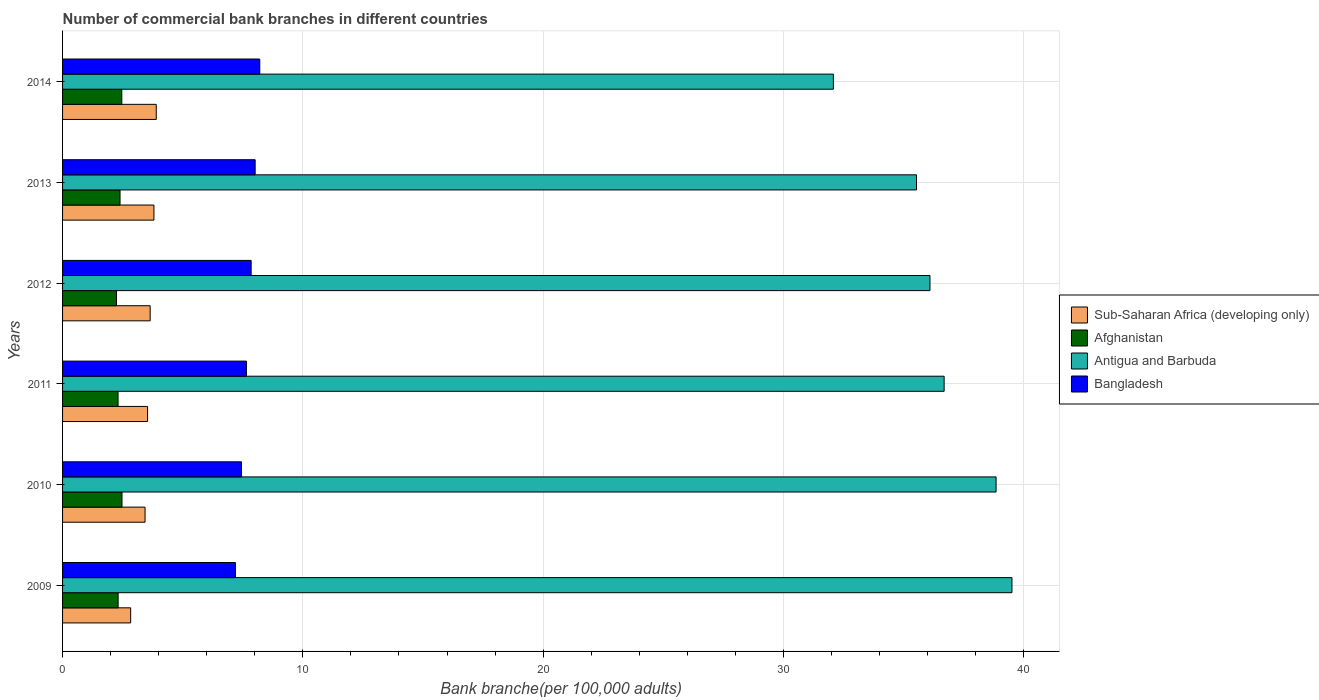How many different coloured bars are there?
Make the answer very short. 4. Are the number of bars on each tick of the Y-axis equal?
Provide a succinct answer. Yes. What is the label of the 1st group of bars from the top?
Give a very brief answer. 2014. What is the number of commercial bank branches in Antigua and Barbuda in 2009?
Keep it short and to the point. 39.51. Across all years, what is the maximum number of commercial bank branches in Afghanistan?
Provide a succinct answer. 2.47. Across all years, what is the minimum number of commercial bank branches in Antigua and Barbuda?
Your answer should be very brief. 32.08. What is the total number of commercial bank branches in Bangladesh in the graph?
Provide a succinct answer. 46.36. What is the difference between the number of commercial bank branches in Afghanistan in 2010 and that in 2011?
Provide a short and direct response. 0.16. What is the difference between the number of commercial bank branches in Bangladesh in 2014 and the number of commercial bank branches in Afghanistan in 2013?
Offer a terse response. 5.82. What is the average number of commercial bank branches in Afghanistan per year?
Provide a succinct answer. 2.37. In the year 2009, what is the difference between the number of commercial bank branches in Antigua and Barbuda and number of commercial bank branches in Sub-Saharan Africa (developing only)?
Offer a terse response. 36.68. In how many years, is the number of commercial bank branches in Antigua and Barbuda greater than 6 ?
Provide a succinct answer. 6. What is the ratio of the number of commercial bank branches in Afghanistan in 2012 to that in 2013?
Keep it short and to the point. 0.94. Is the number of commercial bank branches in Afghanistan in 2010 less than that in 2014?
Provide a succinct answer. No. Is the difference between the number of commercial bank branches in Antigua and Barbuda in 2011 and 2013 greater than the difference between the number of commercial bank branches in Sub-Saharan Africa (developing only) in 2011 and 2013?
Your answer should be very brief. Yes. What is the difference between the highest and the second highest number of commercial bank branches in Sub-Saharan Africa (developing only)?
Offer a very short reply. 0.1. What is the difference between the highest and the lowest number of commercial bank branches in Sub-Saharan Africa (developing only)?
Ensure brevity in your answer.  1.07. In how many years, is the number of commercial bank branches in Bangladesh greater than the average number of commercial bank branches in Bangladesh taken over all years?
Give a very brief answer. 3. Is it the case that in every year, the sum of the number of commercial bank branches in Antigua and Barbuda and number of commercial bank branches in Afghanistan is greater than the sum of number of commercial bank branches in Bangladesh and number of commercial bank branches in Sub-Saharan Africa (developing only)?
Your answer should be compact. Yes. What does the 3rd bar from the top in 2011 represents?
Give a very brief answer. Afghanistan. What does the 3rd bar from the bottom in 2014 represents?
Offer a terse response. Antigua and Barbuda. How many years are there in the graph?
Keep it short and to the point. 6. What is the difference between two consecutive major ticks on the X-axis?
Provide a succinct answer. 10. How many legend labels are there?
Offer a terse response. 4. How are the legend labels stacked?
Provide a succinct answer. Vertical. What is the title of the graph?
Offer a very short reply. Number of commercial bank branches in different countries. Does "Slovak Republic" appear as one of the legend labels in the graph?
Offer a very short reply. No. What is the label or title of the X-axis?
Ensure brevity in your answer.  Bank branche(per 100,0 adults). What is the label or title of the Y-axis?
Provide a short and direct response. Years. What is the Bank branche(per 100,000 adults) of Sub-Saharan Africa (developing only) in 2009?
Give a very brief answer. 2.83. What is the Bank branche(per 100,000 adults) of Afghanistan in 2009?
Your response must be concise. 2.31. What is the Bank branche(per 100,000 adults) of Antigua and Barbuda in 2009?
Your answer should be compact. 39.51. What is the Bank branche(per 100,000 adults) in Bangladesh in 2009?
Offer a very short reply. 7.19. What is the Bank branche(per 100,000 adults) in Sub-Saharan Africa (developing only) in 2010?
Provide a short and direct response. 3.43. What is the Bank branche(per 100,000 adults) of Afghanistan in 2010?
Offer a very short reply. 2.47. What is the Bank branche(per 100,000 adults) of Antigua and Barbuda in 2010?
Your answer should be compact. 38.85. What is the Bank branche(per 100,000 adults) in Bangladesh in 2010?
Offer a very short reply. 7.44. What is the Bank branche(per 100,000 adults) in Sub-Saharan Africa (developing only) in 2011?
Offer a very short reply. 3.54. What is the Bank branche(per 100,000 adults) of Afghanistan in 2011?
Offer a terse response. 2.31. What is the Bank branche(per 100,000 adults) of Antigua and Barbuda in 2011?
Provide a succinct answer. 36.69. What is the Bank branche(per 100,000 adults) in Bangladesh in 2011?
Your response must be concise. 7.65. What is the Bank branche(per 100,000 adults) in Sub-Saharan Africa (developing only) in 2012?
Offer a very short reply. 3.65. What is the Bank branche(per 100,000 adults) in Afghanistan in 2012?
Offer a terse response. 2.24. What is the Bank branche(per 100,000 adults) in Antigua and Barbuda in 2012?
Keep it short and to the point. 36.1. What is the Bank branche(per 100,000 adults) of Bangladesh in 2012?
Your response must be concise. 7.85. What is the Bank branche(per 100,000 adults) of Sub-Saharan Africa (developing only) in 2013?
Provide a short and direct response. 3.8. What is the Bank branche(per 100,000 adults) of Afghanistan in 2013?
Your response must be concise. 2.39. What is the Bank branche(per 100,000 adults) in Antigua and Barbuda in 2013?
Offer a terse response. 35.54. What is the Bank branche(per 100,000 adults) of Bangladesh in 2013?
Your answer should be compact. 8.02. What is the Bank branche(per 100,000 adults) of Sub-Saharan Africa (developing only) in 2014?
Ensure brevity in your answer.  3.9. What is the Bank branche(per 100,000 adults) in Afghanistan in 2014?
Your answer should be very brief. 2.47. What is the Bank branche(per 100,000 adults) of Antigua and Barbuda in 2014?
Offer a terse response. 32.08. What is the Bank branche(per 100,000 adults) of Bangladesh in 2014?
Your answer should be compact. 8.21. Across all years, what is the maximum Bank branche(per 100,000 adults) in Sub-Saharan Africa (developing only)?
Provide a succinct answer. 3.9. Across all years, what is the maximum Bank branche(per 100,000 adults) of Afghanistan?
Offer a very short reply. 2.47. Across all years, what is the maximum Bank branche(per 100,000 adults) in Antigua and Barbuda?
Keep it short and to the point. 39.51. Across all years, what is the maximum Bank branche(per 100,000 adults) of Bangladesh?
Provide a succinct answer. 8.21. Across all years, what is the minimum Bank branche(per 100,000 adults) in Sub-Saharan Africa (developing only)?
Offer a terse response. 2.83. Across all years, what is the minimum Bank branche(per 100,000 adults) of Afghanistan?
Your answer should be compact. 2.24. Across all years, what is the minimum Bank branche(per 100,000 adults) in Antigua and Barbuda?
Your answer should be very brief. 32.08. Across all years, what is the minimum Bank branche(per 100,000 adults) in Bangladesh?
Your response must be concise. 7.19. What is the total Bank branche(per 100,000 adults) in Sub-Saharan Africa (developing only) in the graph?
Ensure brevity in your answer.  21.15. What is the total Bank branche(per 100,000 adults) in Afghanistan in the graph?
Give a very brief answer. 14.2. What is the total Bank branche(per 100,000 adults) in Antigua and Barbuda in the graph?
Your answer should be very brief. 218.77. What is the total Bank branche(per 100,000 adults) of Bangladesh in the graph?
Keep it short and to the point. 46.36. What is the difference between the Bank branche(per 100,000 adults) of Sub-Saharan Africa (developing only) in 2009 and that in 2010?
Your answer should be very brief. -0.6. What is the difference between the Bank branche(per 100,000 adults) of Afghanistan in 2009 and that in 2010?
Offer a very short reply. -0.16. What is the difference between the Bank branche(per 100,000 adults) of Antigua and Barbuda in 2009 and that in 2010?
Your response must be concise. 0.66. What is the difference between the Bank branche(per 100,000 adults) of Bangladesh in 2009 and that in 2010?
Offer a very short reply. -0.25. What is the difference between the Bank branche(per 100,000 adults) of Sub-Saharan Africa (developing only) in 2009 and that in 2011?
Offer a very short reply. -0.7. What is the difference between the Bank branche(per 100,000 adults) of Afghanistan in 2009 and that in 2011?
Your answer should be compact. 0. What is the difference between the Bank branche(per 100,000 adults) of Antigua and Barbuda in 2009 and that in 2011?
Your response must be concise. 2.82. What is the difference between the Bank branche(per 100,000 adults) of Bangladesh in 2009 and that in 2011?
Offer a terse response. -0.46. What is the difference between the Bank branche(per 100,000 adults) in Sub-Saharan Africa (developing only) in 2009 and that in 2012?
Offer a very short reply. -0.81. What is the difference between the Bank branche(per 100,000 adults) in Afghanistan in 2009 and that in 2012?
Provide a succinct answer. 0.07. What is the difference between the Bank branche(per 100,000 adults) of Antigua and Barbuda in 2009 and that in 2012?
Provide a short and direct response. 3.41. What is the difference between the Bank branche(per 100,000 adults) in Bangladesh in 2009 and that in 2012?
Give a very brief answer. -0.65. What is the difference between the Bank branche(per 100,000 adults) of Sub-Saharan Africa (developing only) in 2009 and that in 2013?
Make the answer very short. -0.97. What is the difference between the Bank branche(per 100,000 adults) of Afghanistan in 2009 and that in 2013?
Make the answer very short. -0.08. What is the difference between the Bank branche(per 100,000 adults) in Antigua and Barbuda in 2009 and that in 2013?
Provide a succinct answer. 3.97. What is the difference between the Bank branche(per 100,000 adults) in Bangladesh in 2009 and that in 2013?
Provide a succinct answer. -0.82. What is the difference between the Bank branche(per 100,000 adults) in Sub-Saharan Africa (developing only) in 2009 and that in 2014?
Keep it short and to the point. -1.07. What is the difference between the Bank branche(per 100,000 adults) of Afghanistan in 2009 and that in 2014?
Offer a terse response. -0.15. What is the difference between the Bank branche(per 100,000 adults) in Antigua and Barbuda in 2009 and that in 2014?
Provide a succinct answer. 7.43. What is the difference between the Bank branche(per 100,000 adults) of Bangladesh in 2009 and that in 2014?
Provide a succinct answer. -1.01. What is the difference between the Bank branche(per 100,000 adults) in Sub-Saharan Africa (developing only) in 2010 and that in 2011?
Provide a short and direct response. -0.11. What is the difference between the Bank branche(per 100,000 adults) in Afghanistan in 2010 and that in 2011?
Offer a very short reply. 0.16. What is the difference between the Bank branche(per 100,000 adults) in Antigua and Barbuda in 2010 and that in 2011?
Ensure brevity in your answer.  2.16. What is the difference between the Bank branche(per 100,000 adults) in Bangladesh in 2010 and that in 2011?
Give a very brief answer. -0.21. What is the difference between the Bank branche(per 100,000 adults) in Sub-Saharan Africa (developing only) in 2010 and that in 2012?
Your response must be concise. -0.21. What is the difference between the Bank branche(per 100,000 adults) in Afghanistan in 2010 and that in 2012?
Offer a very short reply. 0.23. What is the difference between the Bank branche(per 100,000 adults) in Antigua and Barbuda in 2010 and that in 2012?
Give a very brief answer. 2.75. What is the difference between the Bank branche(per 100,000 adults) of Bangladesh in 2010 and that in 2012?
Provide a succinct answer. -0.4. What is the difference between the Bank branche(per 100,000 adults) of Sub-Saharan Africa (developing only) in 2010 and that in 2013?
Your answer should be very brief. -0.37. What is the difference between the Bank branche(per 100,000 adults) of Afghanistan in 2010 and that in 2013?
Give a very brief answer. 0.08. What is the difference between the Bank branche(per 100,000 adults) of Antigua and Barbuda in 2010 and that in 2013?
Offer a terse response. 3.31. What is the difference between the Bank branche(per 100,000 adults) of Bangladesh in 2010 and that in 2013?
Keep it short and to the point. -0.57. What is the difference between the Bank branche(per 100,000 adults) in Sub-Saharan Africa (developing only) in 2010 and that in 2014?
Give a very brief answer. -0.47. What is the difference between the Bank branche(per 100,000 adults) of Afghanistan in 2010 and that in 2014?
Make the answer very short. 0.01. What is the difference between the Bank branche(per 100,000 adults) of Antigua and Barbuda in 2010 and that in 2014?
Your answer should be very brief. 6.77. What is the difference between the Bank branche(per 100,000 adults) in Bangladesh in 2010 and that in 2014?
Give a very brief answer. -0.76. What is the difference between the Bank branche(per 100,000 adults) in Sub-Saharan Africa (developing only) in 2011 and that in 2012?
Offer a very short reply. -0.11. What is the difference between the Bank branche(per 100,000 adults) of Afghanistan in 2011 and that in 2012?
Offer a terse response. 0.06. What is the difference between the Bank branche(per 100,000 adults) of Antigua and Barbuda in 2011 and that in 2012?
Make the answer very short. 0.59. What is the difference between the Bank branche(per 100,000 adults) of Bangladesh in 2011 and that in 2012?
Make the answer very short. -0.2. What is the difference between the Bank branche(per 100,000 adults) in Sub-Saharan Africa (developing only) in 2011 and that in 2013?
Your answer should be very brief. -0.26. What is the difference between the Bank branche(per 100,000 adults) of Afghanistan in 2011 and that in 2013?
Give a very brief answer. -0.08. What is the difference between the Bank branche(per 100,000 adults) in Antigua and Barbuda in 2011 and that in 2013?
Keep it short and to the point. 1.15. What is the difference between the Bank branche(per 100,000 adults) of Bangladesh in 2011 and that in 2013?
Make the answer very short. -0.36. What is the difference between the Bank branche(per 100,000 adults) in Sub-Saharan Africa (developing only) in 2011 and that in 2014?
Your answer should be compact. -0.36. What is the difference between the Bank branche(per 100,000 adults) in Afghanistan in 2011 and that in 2014?
Your answer should be very brief. -0.16. What is the difference between the Bank branche(per 100,000 adults) of Antigua and Barbuda in 2011 and that in 2014?
Offer a very short reply. 4.61. What is the difference between the Bank branche(per 100,000 adults) of Bangladesh in 2011 and that in 2014?
Your answer should be very brief. -0.56. What is the difference between the Bank branche(per 100,000 adults) of Sub-Saharan Africa (developing only) in 2012 and that in 2013?
Provide a short and direct response. -0.16. What is the difference between the Bank branche(per 100,000 adults) in Afghanistan in 2012 and that in 2013?
Provide a short and direct response. -0.15. What is the difference between the Bank branche(per 100,000 adults) of Antigua and Barbuda in 2012 and that in 2013?
Ensure brevity in your answer.  0.56. What is the difference between the Bank branche(per 100,000 adults) of Bangladesh in 2012 and that in 2013?
Give a very brief answer. -0.17. What is the difference between the Bank branche(per 100,000 adults) of Sub-Saharan Africa (developing only) in 2012 and that in 2014?
Give a very brief answer. -0.25. What is the difference between the Bank branche(per 100,000 adults) of Afghanistan in 2012 and that in 2014?
Your answer should be compact. -0.22. What is the difference between the Bank branche(per 100,000 adults) in Antigua and Barbuda in 2012 and that in 2014?
Your answer should be very brief. 4.02. What is the difference between the Bank branche(per 100,000 adults) in Bangladesh in 2012 and that in 2014?
Your response must be concise. -0.36. What is the difference between the Bank branche(per 100,000 adults) of Sub-Saharan Africa (developing only) in 2013 and that in 2014?
Your answer should be compact. -0.1. What is the difference between the Bank branche(per 100,000 adults) in Afghanistan in 2013 and that in 2014?
Keep it short and to the point. -0.07. What is the difference between the Bank branche(per 100,000 adults) of Antigua and Barbuda in 2013 and that in 2014?
Make the answer very short. 3.46. What is the difference between the Bank branche(per 100,000 adults) in Bangladesh in 2013 and that in 2014?
Offer a terse response. -0.19. What is the difference between the Bank branche(per 100,000 adults) of Sub-Saharan Africa (developing only) in 2009 and the Bank branche(per 100,000 adults) of Afghanistan in 2010?
Provide a succinct answer. 0.36. What is the difference between the Bank branche(per 100,000 adults) of Sub-Saharan Africa (developing only) in 2009 and the Bank branche(per 100,000 adults) of Antigua and Barbuda in 2010?
Keep it short and to the point. -36.02. What is the difference between the Bank branche(per 100,000 adults) of Sub-Saharan Africa (developing only) in 2009 and the Bank branche(per 100,000 adults) of Bangladesh in 2010?
Give a very brief answer. -4.61. What is the difference between the Bank branche(per 100,000 adults) of Afghanistan in 2009 and the Bank branche(per 100,000 adults) of Antigua and Barbuda in 2010?
Your answer should be very brief. -36.54. What is the difference between the Bank branche(per 100,000 adults) of Afghanistan in 2009 and the Bank branche(per 100,000 adults) of Bangladesh in 2010?
Make the answer very short. -5.13. What is the difference between the Bank branche(per 100,000 adults) in Antigua and Barbuda in 2009 and the Bank branche(per 100,000 adults) in Bangladesh in 2010?
Offer a terse response. 32.07. What is the difference between the Bank branche(per 100,000 adults) of Sub-Saharan Africa (developing only) in 2009 and the Bank branche(per 100,000 adults) of Afghanistan in 2011?
Your answer should be very brief. 0.52. What is the difference between the Bank branche(per 100,000 adults) of Sub-Saharan Africa (developing only) in 2009 and the Bank branche(per 100,000 adults) of Antigua and Barbuda in 2011?
Your response must be concise. -33.85. What is the difference between the Bank branche(per 100,000 adults) in Sub-Saharan Africa (developing only) in 2009 and the Bank branche(per 100,000 adults) in Bangladesh in 2011?
Give a very brief answer. -4.82. What is the difference between the Bank branche(per 100,000 adults) of Afghanistan in 2009 and the Bank branche(per 100,000 adults) of Antigua and Barbuda in 2011?
Your response must be concise. -34.38. What is the difference between the Bank branche(per 100,000 adults) of Afghanistan in 2009 and the Bank branche(per 100,000 adults) of Bangladesh in 2011?
Provide a succinct answer. -5.34. What is the difference between the Bank branche(per 100,000 adults) in Antigua and Barbuda in 2009 and the Bank branche(per 100,000 adults) in Bangladesh in 2011?
Ensure brevity in your answer.  31.86. What is the difference between the Bank branche(per 100,000 adults) in Sub-Saharan Africa (developing only) in 2009 and the Bank branche(per 100,000 adults) in Afghanistan in 2012?
Make the answer very short. 0.59. What is the difference between the Bank branche(per 100,000 adults) in Sub-Saharan Africa (developing only) in 2009 and the Bank branche(per 100,000 adults) in Antigua and Barbuda in 2012?
Provide a short and direct response. -33.26. What is the difference between the Bank branche(per 100,000 adults) in Sub-Saharan Africa (developing only) in 2009 and the Bank branche(per 100,000 adults) in Bangladesh in 2012?
Make the answer very short. -5.01. What is the difference between the Bank branche(per 100,000 adults) of Afghanistan in 2009 and the Bank branche(per 100,000 adults) of Antigua and Barbuda in 2012?
Keep it short and to the point. -33.79. What is the difference between the Bank branche(per 100,000 adults) of Afghanistan in 2009 and the Bank branche(per 100,000 adults) of Bangladesh in 2012?
Your answer should be compact. -5.54. What is the difference between the Bank branche(per 100,000 adults) of Antigua and Barbuda in 2009 and the Bank branche(per 100,000 adults) of Bangladesh in 2012?
Your answer should be very brief. 31.66. What is the difference between the Bank branche(per 100,000 adults) of Sub-Saharan Africa (developing only) in 2009 and the Bank branche(per 100,000 adults) of Afghanistan in 2013?
Your answer should be very brief. 0.44. What is the difference between the Bank branche(per 100,000 adults) of Sub-Saharan Africa (developing only) in 2009 and the Bank branche(per 100,000 adults) of Antigua and Barbuda in 2013?
Provide a short and direct response. -32.7. What is the difference between the Bank branche(per 100,000 adults) of Sub-Saharan Africa (developing only) in 2009 and the Bank branche(per 100,000 adults) of Bangladesh in 2013?
Ensure brevity in your answer.  -5.18. What is the difference between the Bank branche(per 100,000 adults) of Afghanistan in 2009 and the Bank branche(per 100,000 adults) of Antigua and Barbuda in 2013?
Keep it short and to the point. -33.23. What is the difference between the Bank branche(per 100,000 adults) of Afghanistan in 2009 and the Bank branche(per 100,000 adults) of Bangladesh in 2013?
Offer a very short reply. -5.7. What is the difference between the Bank branche(per 100,000 adults) in Antigua and Barbuda in 2009 and the Bank branche(per 100,000 adults) in Bangladesh in 2013?
Offer a terse response. 31.5. What is the difference between the Bank branche(per 100,000 adults) of Sub-Saharan Africa (developing only) in 2009 and the Bank branche(per 100,000 adults) of Afghanistan in 2014?
Make the answer very short. 0.37. What is the difference between the Bank branche(per 100,000 adults) of Sub-Saharan Africa (developing only) in 2009 and the Bank branche(per 100,000 adults) of Antigua and Barbuda in 2014?
Ensure brevity in your answer.  -29.25. What is the difference between the Bank branche(per 100,000 adults) of Sub-Saharan Africa (developing only) in 2009 and the Bank branche(per 100,000 adults) of Bangladesh in 2014?
Your response must be concise. -5.37. What is the difference between the Bank branche(per 100,000 adults) of Afghanistan in 2009 and the Bank branche(per 100,000 adults) of Antigua and Barbuda in 2014?
Provide a succinct answer. -29.77. What is the difference between the Bank branche(per 100,000 adults) of Afghanistan in 2009 and the Bank branche(per 100,000 adults) of Bangladesh in 2014?
Your answer should be very brief. -5.89. What is the difference between the Bank branche(per 100,000 adults) in Antigua and Barbuda in 2009 and the Bank branche(per 100,000 adults) in Bangladesh in 2014?
Your answer should be very brief. 31.3. What is the difference between the Bank branche(per 100,000 adults) in Sub-Saharan Africa (developing only) in 2010 and the Bank branche(per 100,000 adults) in Afghanistan in 2011?
Give a very brief answer. 1.12. What is the difference between the Bank branche(per 100,000 adults) of Sub-Saharan Africa (developing only) in 2010 and the Bank branche(per 100,000 adults) of Antigua and Barbuda in 2011?
Provide a succinct answer. -33.26. What is the difference between the Bank branche(per 100,000 adults) of Sub-Saharan Africa (developing only) in 2010 and the Bank branche(per 100,000 adults) of Bangladesh in 2011?
Offer a terse response. -4.22. What is the difference between the Bank branche(per 100,000 adults) of Afghanistan in 2010 and the Bank branche(per 100,000 adults) of Antigua and Barbuda in 2011?
Your response must be concise. -34.22. What is the difference between the Bank branche(per 100,000 adults) in Afghanistan in 2010 and the Bank branche(per 100,000 adults) in Bangladesh in 2011?
Give a very brief answer. -5.18. What is the difference between the Bank branche(per 100,000 adults) in Antigua and Barbuda in 2010 and the Bank branche(per 100,000 adults) in Bangladesh in 2011?
Provide a short and direct response. 31.2. What is the difference between the Bank branche(per 100,000 adults) of Sub-Saharan Africa (developing only) in 2010 and the Bank branche(per 100,000 adults) of Afghanistan in 2012?
Give a very brief answer. 1.19. What is the difference between the Bank branche(per 100,000 adults) in Sub-Saharan Africa (developing only) in 2010 and the Bank branche(per 100,000 adults) in Antigua and Barbuda in 2012?
Provide a short and direct response. -32.67. What is the difference between the Bank branche(per 100,000 adults) of Sub-Saharan Africa (developing only) in 2010 and the Bank branche(per 100,000 adults) of Bangladesh in 2012?
Give a very brief answer. -4.42. What is the difference between the Bank branche(per 100,000 adults) of Afghanistan in 2010 and the Bank branche(per 100,000 adults) of Antigua and Barbuda in 2012?
Your answer should be compact. -33.63. What is the difference between the Bank branche(per 100,000 adults) in Afghanistan in 2010 and the Bank branche(per 100,000 adults) in Bangladesh in 2012?
Give a very brief answer. -5.37. What is the difference between the Bank branche(per 100,000 adults) of Antigua and Barbuda in 2010 and the Bank branche(per 100,000 adults) of Bangladesh in 2012?
Provide a succinct answer. 31. What is the difference between the Bank branche(per 100,000 adults) in Sub-Saharan Africa (developing only) in 2010 and the Bank branche(per 100,000 adults) in Afghanistan in 2013?
Your answer should be very brief. 1.04. What is the difference between the Bank branche(per 100,000 adults) in Sub-Saharan Africa (developing only) in 2010 and the Bank branche(per 100,000 adults) in Antigua and Barbuda in 2013?
Ensure brevity in your answer.  -32.11. What is the difference between the Bank branche(per 100,000 adults) in Sub-Saharan Africa (developing only) in 2010 and the Bank branche(per 100,000 adults) in Bangladesh in 2013?
Your answer should be very brief. -4.58. What is the difference between the Bank branche(per 100,000 adults) of Afghanistan in 2010 and the Bank branche(per 100,000 adults) of Antigua and Barbuda in 2013?
Ensure brevity in your answer.  -33.07. What is the difference between the Bank branche(per 100,000 adults) in Afghanistan in 2010 and the Bank branche(per 100,000 adults) in Bangladesh in 2013?
Provide a succinct answer. -5.54. What is the difference between the Bank branche(per 100,000 adults) in Antigua and Barbuda in 2010 and the Bank branche(per 100,000 adults) in Bangladesh in 2013?
Make the answer very short. 30.84. What is the difference between the Bank branche(per 100,000 adults) of Sub-Saharan Africa (developing only) in 2010 and the Bank branche(per 100,000 adults) of Afghanistan in 2014?
Provide a short and direct response. 0.97. What is the difference between the Bank branche(per 100,000 adults) of Sub-Saharan Africa (developing only) in 2010 and the Bank branche(per 100,000 adults) of Antigua and Barbuda in 2014?
Your response must be concise. -28.65. What is the difference between the Bank branche(per 100,000 adults) of Sub-Saharan Africa (developing only) in 2010 and the Bank branche(per 100,000 adults) of Bangladesh in 2014?
Make the answer very short. -4.77. What is the difference between the Bank branche(per 100,000 adults) of Afghanistan in 2010 and the Bank branche(per 100,000 adults) of Antigua and Barbuda in 2014?
Provide a short and direct response. -29.61. What is the difference between the Bank branche(per 100,000 adults) in Afghanistan in 2010 and the Bank branche(per 100,000 adults) in Bangladesh in 2014?
Your answer should be very brief. -5.73. What is the difference between the Bank branche(per 100,000 adults) of Antigua and Barbuda in 2010 and the Bank branche(per 100,000 adults) of Bangladesh in 2014?
Offer a terse response. 30.64. What is the difference between the Bank branche(per 100,000 adults) in Sub-Saharan Africa (developing only) in 2011 and the Bank branche(per 100,000 adults) in Afghanistan in 2012?
Make the answer very short. 1.29. What is the difference between the Bank branche(per 100,000 adults) in Sub-Saharan Africa (developing only) in 2011 and the Bank branche(per 100,000 adults) in Antigua and Barbuda in 2012?
Your response must be concise. -32.56. What is the difference between the Bank branche(per 100,000 adults) in Sub-Saharan Africa (developing only) in 2011 and the Bank branche(per 100,000 adults) in Bangladesh in 2012?
Offer a terse response. -4.31. What is the difference between the Bank branche(per 100,000 adults) of Afghanistan in 2011 and the Bank branche(per 100,000 adults) of Antigua and Barbuda in 2012?
Your answer should be compact. -33.79. What is the difference between the Bank branche(per 100,000 adults) of Afghanistan in 2011 and the Bank branche(per 100,000 adults) of Bangladesh in 2012?
Make the answer very short. -5.54. What is the difference between the Bank branche(per 100,000 adults) of Antigua and Barbuda in 2011 and the Bank branche(per 100,000 adults) of Bangladesh in 2012?
Your answer should be compact. 28.84. What is the difference between the Bank branche(per 100,000 adults) in Sub-Saharan Africa (developing only) in 2011 and the Bank branche(per 100,000 adults) in Afghanistan in 2013?
Your answer should be compact. 1.15. What is the difference between the Bank branche(per 100,000 adults) in Sub-Saharan Africa (developing only) in 2011 and the Bank branche(per 100,000 adults) in Antigua and Barbuda in 2013?
Give a very brief answer. -32. What is the difference between the Bank branche(per 100,000 adults) in Sub-Saharan Africa (developing only) in 2011 and the Bank branche(per 100,000 adults) in Bangladesh in 2013?
Your answer should be compact. -4.48. What is the difference between the Bank branche(per 100,000 adults) in Afghanistan in 2011 and the Bank branche(per 100,000 adults) in Antigua and Barbuda in 2013?
Provide a short and direct response. -33.23. What is the difference between the Bank branche(per 100,000 adults) of Afghanistan in 2011 and the Bank branche(per 100,000 adults) of Bangladesh in 2013?
Ensure brevity in your answer.  -5.71. What is the difference between the Bank branche(per 100,000 adults) in Antigua and Barbuda in 2011 and the Bank branche(per 100,000 adults) in Bangladesh in 2013?
Keep it short and to the point. 28.67. What is the difference between the Bank branche(per 100,000 adults) of Sub-Saharan Africa (developing only) in 2011 and the Bank branche(per 100,000 adults) of Afghanistan in 2014?
Your answer should be very brief. 1.07. What is the difference between the Bank branche(per 100,000 adults) in Sub-Saharan Africa (developing only) in 2011 and the Bank branche(per 100,000 adults) in Antigua and Barbuda in 2014?
Offer a very short reply. -28.54. What is the difference between the Bank branche(per 100,000 adults) in Sub-Saharan Africa (developing only) in 2011 and the Bank branche(per 100,000 adults) in Bangladesh in 2014?
Give a very brief answer. -4.67. What is the difference between the Bank branche(per 100,000 adults) in Afghanistan in 2011 and the Bank branche(per 100,000 adults) in Antigua and Barbuda in 2014?
Offer a very short reply. -29.77. What is the difference between the Bank branche(per 100,000 adults) in Afghanistan in 2011 and the Bank branche(per 100,000 adults) in Bangladesh in 2014?
Provide a succinct answer. -5.9. What is the difference between the Bank branche(per 100,000 adults) of Antigua and Barbuda in 2011 and the Bank branche(per 100,000 adults) of Bangladesh in 2014?
Provide a succinct answer. 28.48. What is the difference between the Bank branche(per 100,000 adults) in Sub-Saharan Africa (developing only) in 2012 and the Bank branche(per 100,000 adults) in Afghanistan in 2013?
Provide a succinct answer. 1.25. What is the difference between the Bank branche(per 100,000 adults) of Sub-Saharan Africa (developing only) in 2012 and the Bank branche(per 100,000 adults) of Antigua and Barbuda in 2013?
Keep it short and to the point. -31.89. What is the difference between the Bank branche(per 100,000 adults) of Sub-Saharan Africa (developing only) in 2012 and the Bank branche(per 100,000 adults) of Bangladesh in 2013?
Offer a very short reply. -4.37. What is the difference between the Bank branche(per 100,000 adults) in Afghanistan in 2012 and the Bank branche(per 100,000 adults) in Antigua and Barbuda in 2013?
Make the answer very short. -33.29. What is the difference between the Bank branche(per 100,000 adults) of Afghanistan in 2012 and the Bank branche(per 100,000 adults) of Bangladesh in 2013?
Your answer should be very brief. -5.77. What is the difference between the Bank branche(per 100,000 adults) in Antigua and Barbuda in 2012 and the Bank branche(per 100,000 adults) in Bangladesh in 2013?
Your response must be concise. 28.08. What is the difference between the Bank branche(per 100,000 adults) of Sub-Saharan Africa (developing only) in 2012 and the Bank branche(per 100,000 adults) of Afghanistan in 2014?
Offer a terse response. 1.18. What is the difference between the Bank branche(per 100,000 adults) of Sub-Saharan Africa (developing only) in 2012 and the Bank branche(per 100,000 adults) of Antigua and Barbuda in 2014?
Keep it short and to the point. -28.43. What is the difference between the Bank branche(per 100,000 adults) of Sub-Saharan Africa (developing only) in 2012 and the Bank branche(per 100,000 adults) of Bangladesh in 2014?
Keep it short and to the point. -4.56. What is the difference between the Bank branche(per 100,000 adults) of Afghanistan in 2012 and the Bank branche(per 100,000 adults) of Antigua and Barbuda in 2014?
Keep it short and to the point. -29.84. What is the difference between the Bank branche(per 100,000 adults) in Afghanistan in 2012 and the Bank branche(per 100,000 adults) in Bangladesh in 2014?
Provide a short and direct response. -5.96. What is the difference between the Bank branche(per 100,000 adults) in Antigua and Barbuda in 2012 and the Bank branche(per 100,000 adults) in Bangladesh in 2014?
Provide a succinct answer. 27.89. What is the difference between the Bank branche(per 100,000 adults) of Sub-Saharan Africa (developing only) in 2013 and the Bank branche(per 100,000 adults) of Afghanistan in 2014?
Provide a succinct answer. 1.34. What is the difference between the Bank branche(per 100,000 adults) in Sub-Saharan Africa (developing only) in 2013 and the Bank branche(per 100,000 adults) in Antigua and Barbuda in 2014?
Provide a short and direct response. -28.28. What is the difference between the Bank branche(per 100,000 adults) in Sub-Saharan Africa (developing only) in 2013 and the Bank branche(per 100,000 adults) in Bangladesh in 2014?
Ensure brevity in your answer.  -4.4. What is the difference between the Bank branche(per 100,000 adults) of Afghanistan in 2013 and the Bank branche(per 100,000 adults) of Antigua and Barbuda in 2014?
Offer a terse response. -29.69. What is the difference between the Bank branche(per 100,000 adults) in Afghanistan in 2013 and the Bank branche(per 100,000 adults) in Bangladesh in 2014?
Provide a succinct answer. -5.82. What is the difference between the Bank branche(per 100,000 adults) in Antigua and Barbuda in 2013 and the Bank branche(per 100,000 adults) in Bangladesh in 2014?
Provide a succinct answer. 27.33. What is the average Bank branche(per 100,000 adults) in Sub-Saharan Africa (developing only) per year?
Your answer should be very brief. 3.53. What is the average Bank branche(per 100,000 adults) of Afghanistan per year?
Give a very brief answer. 2.37. What is the average Bank branche(per 100,000 adults) of Antigua and Barbuda per year?
Offer a very short reply. 36.46. What is the average Bank branche(per 100,000 adults) in Bangladesh per year?
Offer a terse response. 7.73. In the year 2009, what is the difference between the Bank branche(per 100,000 adults) in Sub-Saharan Africa (developing only) and Bank branche(per 100,000 adults) in Afghanistan?
Ensure brevity in your answer.  0.52. In the year 2009, what is the difference between the Bank branche(per 100,000 adults) of Sub-Saharan Africa (developing only) and Bank branche(per 100,000 adults) of Antigua and Barbuda?
Your response must be concise. -36.68. In the year 2009, what is the difference between the Bank branche(per 100,000 adults) in Sub-Saharan Africa (developing only) and Bank branche(per 100,000 adults) in Bangladesh?
Your answer should be compact. -4.36. In the year 2009, what is the difference between the Bank branche(per 100,000 adults) in Afghanistan and Bank branche(per 100,000 adults) in Antigua and Barbuda?
Your answer should be very brief. -37.2. In the year 2009, what is the difference between the Bank branche(per 100,000 adults) of Afghanistan and Bank branche(per 100,000 adults) of Bangladesh?
Your response must be concise. -4.88. In the year 2009, what is the difference between the Bank branche(per 100,000 adults) in Antigua and Barbuda and Bank branche(per 100,000 adults) in Bangladesh?
Your answer should be compact. 32.32. In the year 2010, what is the difference between the Bank branche(per 100,000 adults) in Sub-Saharan Africa (developing only) and Bank branche(per 100,000 adults) in Afghanistan?
Keep it short and to the point. 0.96. In the year 2010, what is the difference between the Bank branche(per 100,000 adults) of Sub-Saharan Africa (developing only) and Bank branche(per 100,000 adults) of Antigua and Barbuda?
Your answer should be very brief. -35.42. In the year 2010, what is the difference between the Bank branche(per 100,000 adults) in Sub-Saharan Africa (developing only) and Bank branche(per 100,000 adults) in Bangladesh?
Your answer should be compact. -4.01. In the year 2010, what is the difference between the Bank branche(per 100,000 adults) of Afghanistan and Bank branche(per 100,000 adults) of Antigua and Barbuda?
Provide a short and direct response. -36.38. In the year 2010, what is the difference between the Bank branche(per 100,000 adults) in Afghanistan and Bank branche(per 100,000 adults) in Bangladesh?
Provide a short and direct response. -4.97. In the year 2010, what is the difference between the Bank branche(per 100,000 adults) of Antigua and Barbuda and Bank branche(per 100,000 adults) of Bangladesh?
Provide a short and direct response. 31.41. In the year 2011, what is the difference between the Bank branche(per 100,000 adults) in Sub-Saharan Africa (developing only) and Bank branche(per 100,000 adults) in Afghanistan?
Offer a very short reply. 1.23. In the year 2011, what is the difference between the Bank branche(per 100,000 adults) in Sub-Saharan Africa (developing only) and Bank branche(per 100,000 adults) in Antigua and Barbuda?
Provide a short and direct response. -33.15. In the year 2011, what is the difference between the Bank branche(per 100,000 adults) of Sub-Saharan Africa (developing only) and Bank branche(per 100,000 adults) of Bangladesh?
Offer a terse response. -4.11. In the year 2011, what is the difference between the Bank branche(per 100,000 adults) in Afghanistan and Bank branche(per 100,000 adults) in Antigua and Barbuda?
Provide a short and direct response. -34.38. In the year 2011, what is the difference between the Bank branche(per 100,000 adults) of Afghanistan and Bank branche(per 100,000 adults) of Bangladesh?
Ensure brevity in your answer.  -5.34. In the year 2011, what is the difference between the Bank branche(per 100,000 adults) in Antigua and Barbuda and Bank branche(per 100,000 adults) in Bangladesh?
Provide a short and direct response. 29.04. In the year 2012, what is the difference between the Bank branche(per 100,000 adults) of Sub-Saharan Africa (developing only) and Bank branche(per 100,000 adults) of Afghanistan?
Give a very brief answer. 1.4. In the year 2012, what is the difference between the Bank branche(per 100,000 adults) in Sub-Saharan Africa (developing only) and Bank branche(per 100,000 adults) in Antigua and Barbuda?
Give a very brief answer. -32.45. In the year 2012, what is the difference between the Bank branche(per 100,000 adults) in Sub-Saharan Africa (developing only) and Bank branche(per 100,000 adults) in Bangladesh?
Provide a short and direct response. -4.2. In the year 2012, what is the difference between the Bank branche(per 100,000 adults) in Afghanistan and Bank branche(per 100,000 adults) in Antigua and Barbuda?
Provide a succinct answer. -33.85. In the year 2012, what is the difference between the Bank branche(per 100,000 adults) of Afghanistan and Bank branche(per 100,000 adults) of Bangladesh?
Provide a succinct answer. -5.6. In the year 2012, what is the difference between the Bank branche(per 100,000 adults) in Antigua and Barbuda and Bank branche(per 100,000 adults) in Bangladesh?
Offer a very short reply. 28.25. In the year 2013, what is the difference between the Bank branche(per 100,000 adults) in Sub-Saharan Africa (developing only) and Bank branche(per 100,000 adults) in Afghanistan?
Offer a very short reply. 1.41. In the year 2013, what is the difference between the Bank branche(per 100,000 adults) in Sub-Saharan Africa (developing only) and Bank branche(per 100,000 adults) in Antigua and Barbuda?
Make the answer very short. -31.74. In the year 2013, what is the difference between the Bank branche(per 100,000 adults) in Sub-Saharan Africa (developing only) and Bank branche(per 100,000 adults) in Bangladesh?
Your response must be concise. -4.21. In the year 2013, what is the difference between the Bank branche(per 100,000 adults) in Afghanistan and Bank branche(per 100,000 adults) in Antigua and Barbuda?
Give a very brief answer. -33.15. In the year 2013, what is the difference between the Bank branche(per 100,000 adults) in Afghanistan and Bank branche(per 100,000 adults) in Bangladesh?
Offer a terse response. -5.62. In the year 2013, what is the difference between the Bank branche(per 100,000 adults) of Antigua and Barbuda and Bank branche(per 100,000 adults) of Bangladesh?
Ensure brevity in your answer.  27.52. In the year 2014, what is the difference between the Bank branche(per 100,000 adults) of Sub-Saharan Africa (developing only) and Bank branche(per 100,000 adults) of Afghanistan?
Ensure brevity in your answer.  1.43. In the year 2014, what is the difference between the Bank branche(per 100,000 adults) in Sub-Saharan Africa (developing only) and Bank branche(per 100,000 adults) in Antigua and Barbuda?
Give a very brief answer. -28.18. In the year 2014, what is the difference between the Bank branche(per 100,000 adults) in Sub-Saharan Africa (developing only) and Bank branche(per 100,000 adults) in Bangladesh?
Keep it short and to the point. -4.31. In the year 2014, what is the difference between the Bank branche(per 100,000 adults) in Afghanistan and Bank branche(per 100,000 adults) in Antigua and Barbuda?
Your answer should be very brief. -29.61. In the year 2014, what is the difference between the Bank branche(per 100,000 adults) of Afghanistan and Bank branche(per 100,000 adults) of Bangladesh?
Offer a terse response. -5.74. In the year 2014, what is the difference between the Bank branche(per 100,000 adults) of Antigua and Barbuda and Bank branche(per 100,000 adults) of Bangladesh?
Make the answer very short. 23.87. What is the ratio of the Bank branche(per 100,000 adults) in Sub-Saharan Africa (developing only) in 2009 to that in 2010?
Ensure brevity in your answer.  0.83. What is the ratio of the Bank branche(per 100,000 adults) in Afghanistan in 2009 to that in 2010?
Make the answer very short. 0.93. What is the ratio of the Bank branche(per 100,000 adults) of Antigua and Barbuda in 2009 to that in 2010?
Keep it short and to the point. 1.02. What is the ratio of the Bank branche(per 100,000 adults) of Bangladesh in 2009 to that in 2010?
Your answer should be very brief. 0.97. What is the ratio of the Bank branche(per 100,000 adults) of Sub-Saharan Africa (developing only) in 2009 to that in 2011?
Offer a very short reply. 0.8. What is the ratio of the Bank branche(per 100,000 adults) in Bangladesh in 2009 to that in 2011?
Offer a terse response. 0.94. What is the ratio of the Bank branche(per 100,000 adults) in Sub-Saharan Africa (developing only) in 2009 to that in 2012?
Your response must be concise. 0.78. What is the ratio of the Bank branche(per 100,000 adults) of Afghanistan in 2009 to that in 2012?
Offer a very short reply. 1.03. What is the ratio of the Bank branche(per 100,000 adults) of Antigua and Barbuda in 2009 to that in 2012?
Provide a short and direct response. 1.09. What is the ratio of the Bank branche(per 100,000 adults) of Bangladesh in 2009 to that in 2012?
Make the answer very short. 0.92. What is the ratio of the Bank branche(per 100,000 adults) in Sub-Saharan Africa (developing only) in 2009 to that in 2013?
Your answer should be compact. 0.75. What is the ratio of the Bank branche(per 100,000 adults) of Afghanistan in 2009 to that in 2013?
Offer a terse response. 0.97. What is the ratio of the Bank branche(per 100,000 adults) in Antigua and Barbuda in 2009 to that in 2013?
Ensure brevity in your answer.  1.11. What is the ratio of the Bank branche(per 100,000 adults) in Bangladesh in 2009 to that in 2013?
Your answer should be compact. 0.9. What is the ratio of the Bank branche(per 100,000 adults) in Sub-Saharan Africa (developing only) in 2009 to that in 2014?
Offer a terse response. 0.73. What is the ratio of the Bank branche(per 100,000 adults) of Afghanistan in 2009 to that in 2014?
Give a very brief answer. 0.94. What is the ratio of the Bank branche(per 100,000 adults) of Antigua and Barbuda in 2009 to that in 2014?
Offer a very short reply. 1.23. What is the ratio of the Bank branche(per 100,000 adults) of Bangladesh in 2009 to that in 2014?
Make the answer very short. 0.88. What is the ratio of the Bank branche(per 100,000 adults) in Sub-Saharan Africa (developing only) in 2010 to that in 2011?
Provide a short and direct response. 0.97. What is the ratio of the Bank branche(per 100,000 adults) of Afghanistan in 2010 to that in 2011?
Keep it short and to the point. 1.07. What is the ratio of the Bank branche(per 100,000 adults) in Antigua and Barbuda in 2010 to that in 2011?
Offer a terse response. 1.06. What is the ratio of the Bank branche(per 100,000 adults) of Sub-Saharan Africa (developing only) in 2010 to that in 2012?
Keep it short and to the point. 0.94. What is the ratio of the Bank branche(per 100,000 adults) in Afghanistan in 2010 to that in 2012?
Keep it short and to the point. 1.1. What is the ratio of the Bank branche(per 100,000 adults) in Antigua and Barbuda in 2010 to that in 2012?
Give a very brief answer. 1.08. What is the ratio of the Bank branche(per 100,000 adults) in Bangladesh in 2010 to that in 2012?
Provide a short and direct response. 0.95. What is the ratio of the Bank branche(per 100,000 adults) of Sub-Saharan Africa (developing only) in 2010 to that in 2013?
Provide a short and direct response. 0.9. What is the ratio of the Bank branche(per 100,000 adults) of Afghanistan in 2010 to that in 2013?
Ensure brevity in your answer.  1.03. What is the ratio of the Bank branche(per 100,000 adults) of Antigua and Barbuda in 2010 to that in 2013?
Your answer should be very brief. 1.09. What is the ratio of the Bank branche(per 100,000 adults) of Bangladesh in 2010 to that in 2013?
Offer a terse response. 0.93. What is the ratio of the Bank branche(per 100,000 adults) of Sub-Saharan Africa (developing only) in 2010 to that in 2014?
Make the answer very short. 0.88. What is the ratio of the Bank branche(per 100,000 adults) in Afghanistan in 2010 to that in 2014?
Your answer should be compact. 1. What is the ratio of the Bank branche(per 100,000 adults) of Antigua and Barbuda in 2010 to that in 2014?
Your answer should be compact. 1.21. What is the ratio of the Bank branche(per 100,000 adults) in Bangladesh in 2010 to that in 2014?
Provide a succinct answer. 0.91. What is the ratio of the Bank branche(per 100,000 adults) of Sub-Saharan Africa (developing only) in 2011 to that in 2012?
Your response must be concise. 0.97. What is the ratio of the Bank branche(per 100,000 adults) of Afghanistan in 2011 to that in 2012?
Provide a short and direct response. 1.03. What is the ratio of the Bank branche(per 100,000 adults) of Antigua and Barbuda in 2011 to that in 2012?
Offer a very short reply. 1.02. What is the ratio of the Bank branche(per 100,000 adults) of Bangladesh in 2011 to that in 2012?
Keep it short and to the point. 0.97. What is the ratio of the Bank branche(per 100,000 adults) in Sub-Saharan Africa (developing only) in 2011 to that in 2013?
Your answer should be very brief. 0.93. What is the ratio of the Bank branche(per 100,000 adults) in Afghanistan in 2011 to that in 2013?
Ensure brevity in your answer.  0.97. What is the ratio of the Bank branche(per 100,000 adults) in Antigua and Barbuda in 2011 to that in 2013?
Your response must be concise. 1.03. What is the ratio of the Bank branche(per 100,000 adults) in Bangladesh in 2011 to that in 2013?
Ensure brevity in your answer.  0.95. What is the ratio of the Bank branche(per 100,000 adults) in Sub-Saharan Africa (developing only) in 2011 to that in 2014?
Provide a short and direct response. 0.91. What is the ratio of the Bank branche(per 100,000 adults) in Afghanistan in 2011 to that in 2014?
Offer a terse response. 0.94. What is the ratio of the Bank branche(per 100,000 adults) in Antigua and Barbuda in 2011 to that in 2014?
Offer a terse response. 1.14. What is the ratio of the Bank branche(per 100,000 adults) in Bangladesh in 2011 to that in 2014?
Offer a terse response. 0.93. What is the ratio of the Bank branche(per 100,000 adults) in Sub-Saharan Africa (developing only) in 2012 to that in 2013?
Keep it short and to the point. 0.96. What is the ratio of the Bank branche(per 100,000 adults) of Afghanistan in 2012 to that in 2013?
Your answer should be compact. 0.94. What is the ratio of the Bank branche(per 100,000 adults) of Antigua and Barbuda in 2012 to that in 2013?
Keep it short and to the point. 1.02. What is the ratio of the Bank branche(per 100,000 adults) of Bangladesh in 2012 to that in 2013?
Give a very brief answer. 0.98. What is the ratio of the Bank branche(per 100,000 adults) in Sub-Saharan Africa (developing only) in 2012 to that in 2014?
Your answer should be very brief. 0.94. What is the ratio of the Bank branche(per 100,000 adults) of Afghanistan in 2012 to that in 2014?
Provide a succinct answer. 0.91. What is the ratio of the Bank branche(per 100,000 adults) of Antigua and Barbuda in 2012 to that in 2014?
Ensure brevity in your answer.  1.13. What is the ratio of the Bank branche(per 100,000 adults) in Bangladesh in 2012 to that in 2014?
Your response must be concise. 0.96. What is the ratio of the Bank branche(per 100,000 adults) of Sub-Saharan Africa (developing only) in 2013 to that in 2014?
Keep it short and to the point. 0.98. What is the ratio of the Bank branche(per 100,000 adults) of Afghanistan in 2013 to that in 2014?
Your answer should be very brief. 0.97. What is the ratio of the Bank branche(per 100,000 adults) of Antigua and Barbuda in 2013 to that in 2014?
Your answer should be compact. 1.11. What is the ratio of the Bank branche(per 100,000 adults) of Bangladesh in 2013 to that in 2014?
Keep it short and to the point. 0.98. What is the difference between the highest and the second highest Bank branche(per 100,000 adults) of Sub-Saharan Africa (developing only)?
Give a very brief answer. 0.1. What is the difference between the highest and the second highest Bank branche(per 100,000 adults) in Afghanistan?
Offer a very short reply. 0.01. What is the difference between the highest and the second highest Bank branche(per 100,000 adults) of Antigua and Barbuda?
Make the answer very short. 0.66. What is the difference between the highest and the second highest Bank branche(per 100,000 adults) in Bangladesh?
Make the answer very short. 0.19. What is the difference between the highest and the lowest Bank branche(per 100,000 adults) in Sub-Saharan Africa (developing only)?
Your answer should be compact. 1.07. What is the difference between the highest and the lowest Bank branche(per 100,000 adults) of Afghanistan?
Offer a terse response. 0.23. What is the difference between the highest and the lowest Bank branche(per 100,000 adults) of Antigua and Barbuda?
Provide a succinct answer. 7.43. 